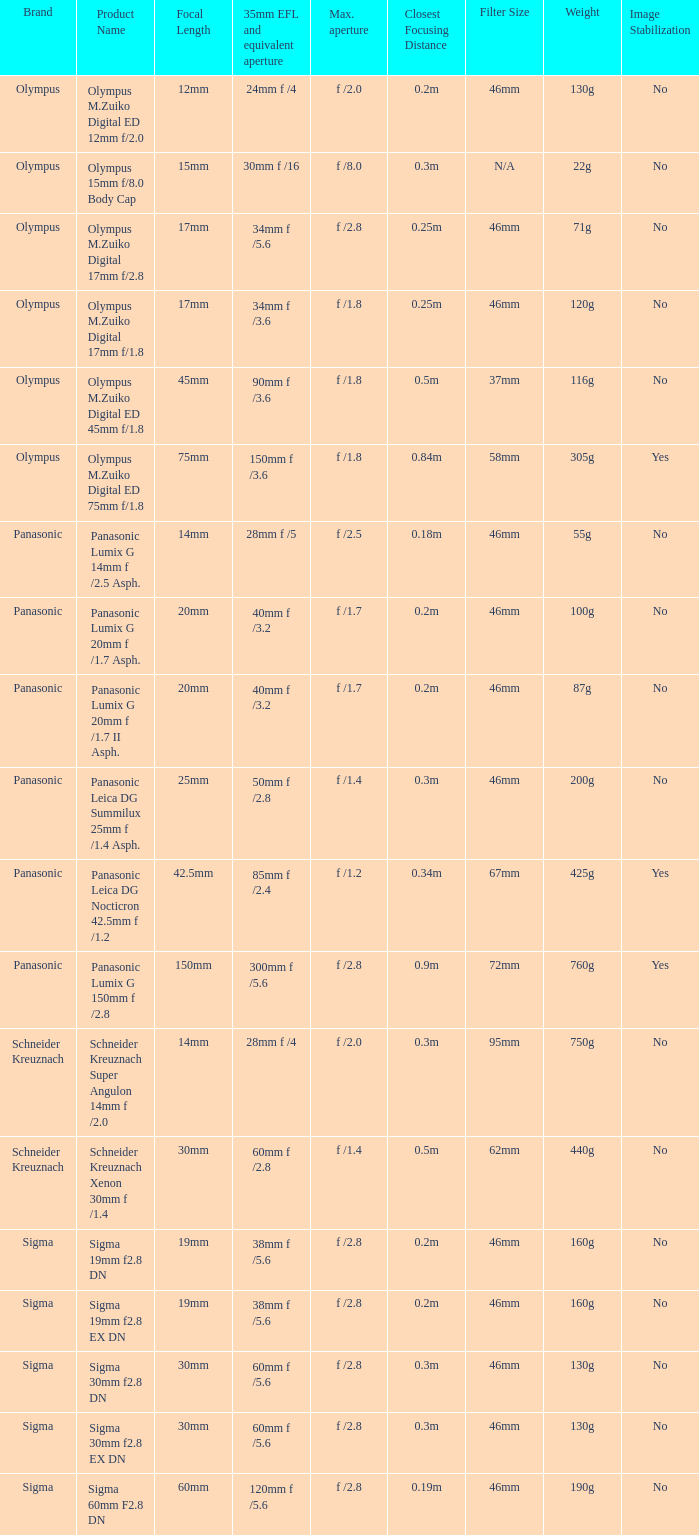What is the maximum aperture of the lens(es) with a focal length of 20mm? F /1.7, f /1.7. 